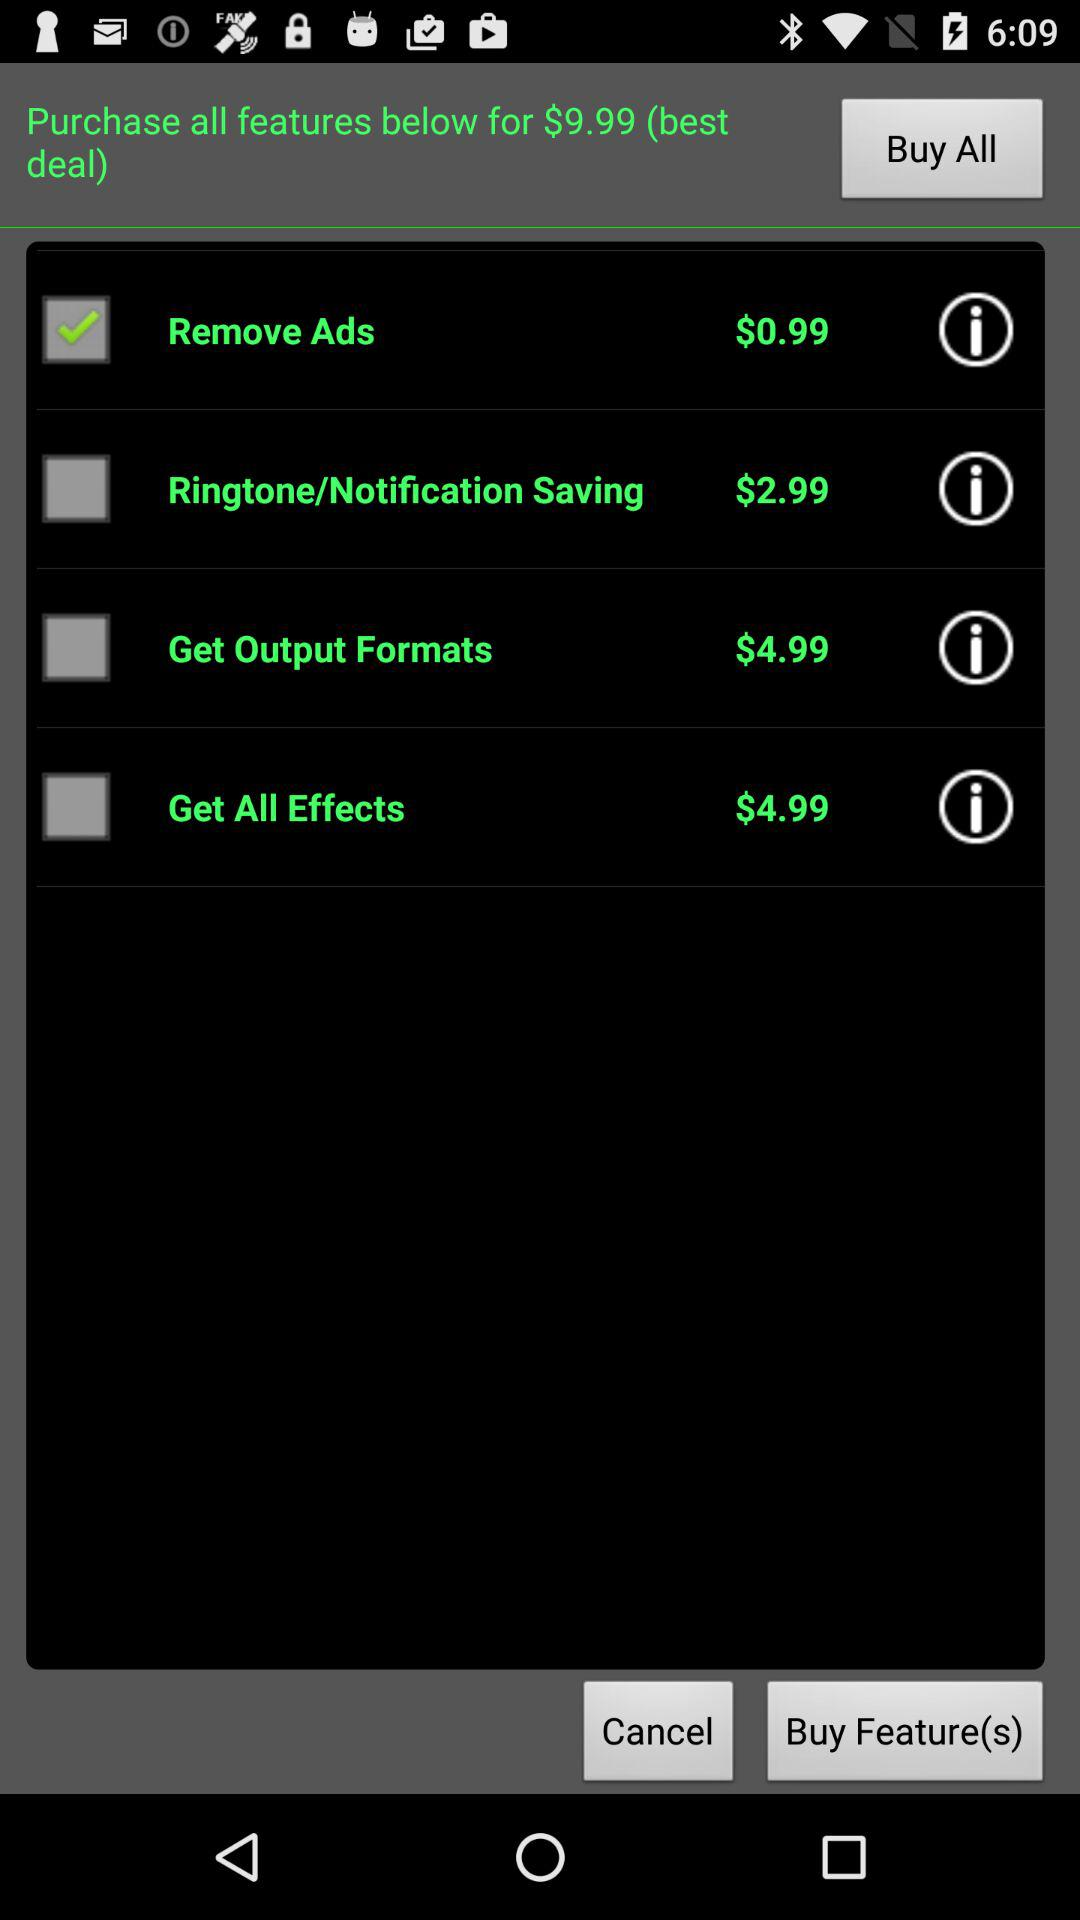What is the purchase price of "Get All Effects"? The purchase price is $4.99. 